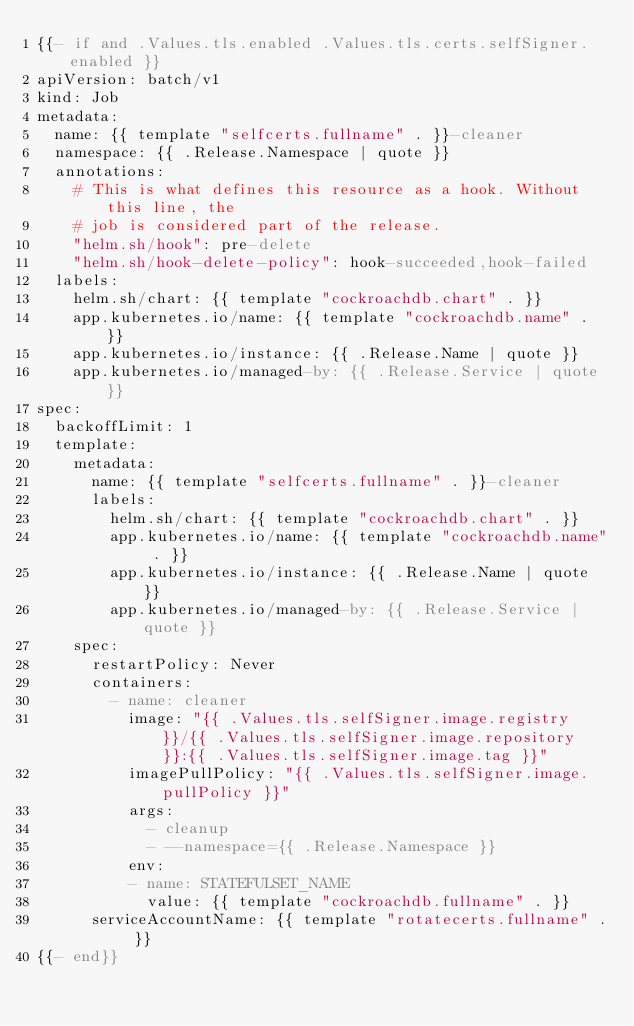<code> <loc_0><loc_0><loc_500><loc_500><_YAML_>{{- if and .Values.tls.enabled .Values.tls.certs.selfSigner.enabled }}
apiVersion: batch/v1
kind: Job
metadata:
  name: {{ template "selfcerts.fullname" . }}-cleaner
  namespace: {{ .Release.Namespace | quote }}
  annotations:
    # This is what defines this resource as a hook. Without this line, the
    # job is considered part of the release.
    "helm.sh/hook": pre-delete
    "helm.sh/hook-delete-policy": hook-succeeded,hook-failed
  labels:
    helm.sh/chart: {{ template "cockroachdb.chart" . }}
    app.kubernetes.io/name: {{ template "cockroachdb.name" . }}
    app.kubernetes.io/instance: {{ .Release.Name | quote }}
    app.kubernetes.io/managed-by: {{ .Release.Service | quote }}
spec:
  backoffLimit: 1
  template:
    metadata:
      name: {{ template "selfcerts.fullname" . }}-cleaner
      labels:
        helm.sh/chart: {{ template "cockroachdb.chart" . }}
        app.kubernetes.io/name: {{ template "cockroachdb.name" . }}
        app.kubernetes.io/instance: {{ .Release.Name | quote }}
        app.kubernetes.io/managed-by: {{ .Release.Service | quote }}
    spec:
      restartPolicy: Never
      containers:
        - name: cleaner
          image: "{{ .Values.tls.selfSigner.image.registry }}/{{ .Values.tls.selfSigner.image.repository }}:{{ .Values.tls.selfSigner.image.tag }}"
          imagePullPolicy: "{{ .Values.tls.selfSigner.image.pullPolicy }}"
          args:
            - cleanup
            - --namespace={{ .Release.Namespace }}
          env:
          - name: STATEFULSET_NAME
            value: {{ template "cockroachdb.fullname" . }}
      serviceAccountName: {{ template "rotatecerts.fullname" . }}
{{- end}}
</code> 